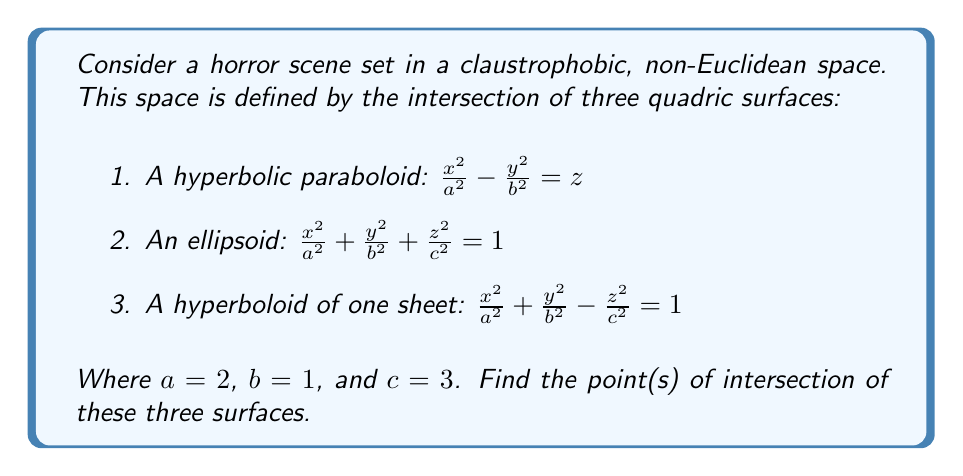Can you answer this question? To find the intersection points, we need to solve the system of equations:

1. $\frac{x^2}{4} - y^2 = z$
2. $\frac{x^2}{4} + y^2 + \frac{z^2}{9} = 1$
3. $\frac{x^2}{4} + y^2 - \frac{z^2}{9} = 1$

Step 1: Subtract equation 3 from equation 2:
$\frac{z^2}{9} - (-\frac{z^2}{9}) = 1 - 1$
$\frac{2z^2}{9} = 0$
$z^2 = 0$
$z = 0$

Step 2: Substitute $z = 0$ into equation 1:
$\frac{x^2}{4} - y^2 = 0$

Step 3: Substitute $z = 0$ into equation 2 or 3:
$\frac{x^2}{4} + y^2 = 1$

Step 4: Solve the system of equations from steps 2 and 3:
$y^2 = \frac{x^2}{4}$ (from step 2)
Substitute this into the equation from step 3:
$\frac{x^2}{4} + \frac{x^2}{4} = 1$
$\frac{x^2}{2} = 1$
$x^2 = 2$
$x = \pm\sqrt{2}$

Step 5: Find $y$ using the equation from step 2:
$y^2 = \frac{x^2}{4} = \frac{2}{4} = \frac{1}{2}$
$y = \pm\frac{1}{\sqrt{2}}$

Therefore, the points of intersection are:
$(\sqrt{2}, \frac{1}{\sqrt{2}}, 0)$, $(\sqrt{2}, -\frac{1}{\sqrt{2}}, 0)$, $(-\sqrt{2}, \frac{1}{\sqrt{2}}, 0)$, and $(-\sqrt{2}, -\frac{1}{\sqrt{2}}, 0)$.
Answer: $(\pm\sqrt{2}, \pm\frac{1}{\sqrt{2}}, 0)$ 